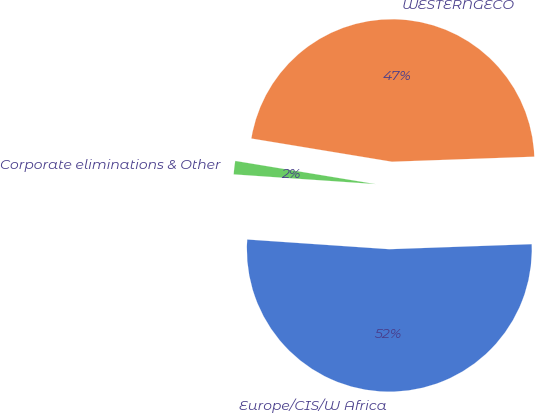Convert chart to OTSL. <chart><loc_0><loc_0><loc_500><loc_500><pie_chart><fcel>Europe/CIS/W Africa<fcel>WESTERNGECO<fcel>Corporate eliminations & Other<nl><fcel>51.65%<fcel>46.83%<fcel>1.52%<nl></chart> 